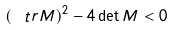Convert formula to latex. <formula><loc_0><loc_0><loc_500><loc_500>\left ( \ t r M \right ) ^ { 2 } - 4 \det M < 0</formula> 